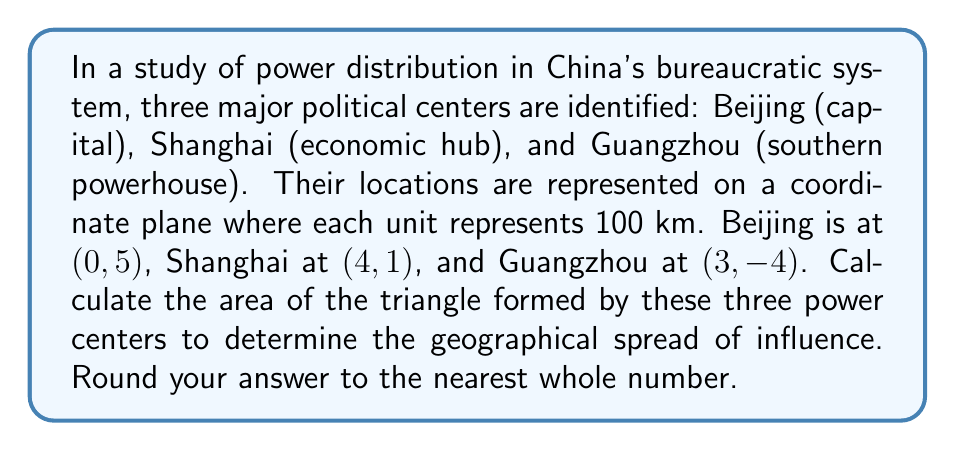Can you answer this question? To solve this problem, we'll use the following steps:

1) First, recall the formula for the area of a triangle given the coordinates of its vertices:

   Area = $\frac{1}{2}|x_1(y_2 - y_3) + x_2(y_3 - y_1) + x_3(y_1 - y_2)|$

   Where $(x_1, y_1)$, $(x_2, y_2)$, and $(x_3, y_3)$ are the coordinates of the three vertices.

2) Let's assign our coordinates:
   Beijing: $(x_1, y_1) = (0, 5)$
   Shanghai: $(x_2, y_2) = (4, 1)$
   Guangzhou: $(x_3, y_3) = (3, -4)$

3) Now, let's substitute these into our formula:

   Area = $\frac{1}{2}|0(1 - (-4)) + 4((-4) - 5) + 3(5 - 1)|$

4) Simplify the expressions inside the parentheses:

   Area = $\frac{1}{2}|0(5) + 4(-9) + 3(4)|$

5) Multiply:

   Area = $\frac{1}{2}|0 - 36 + 12|$

6) Add inside the absolute value signs:

   Area = $\frac{1}{2}|-24|$

7) Evaluate the absolute value:

   Area = $\frac{1}{2}(24)$

8) Calculate:

   Area = 12

9) Remember that each unit represents 100 km, so the actual area is:

   12 * 100^2 = 120,000 km^2

10) Rounding to the nearest whole number:

    120,000 km^2

This area represents the geographical spread of influence among these three major power centers in China's bureaucratic system.
Answer: 120,000 km^2 